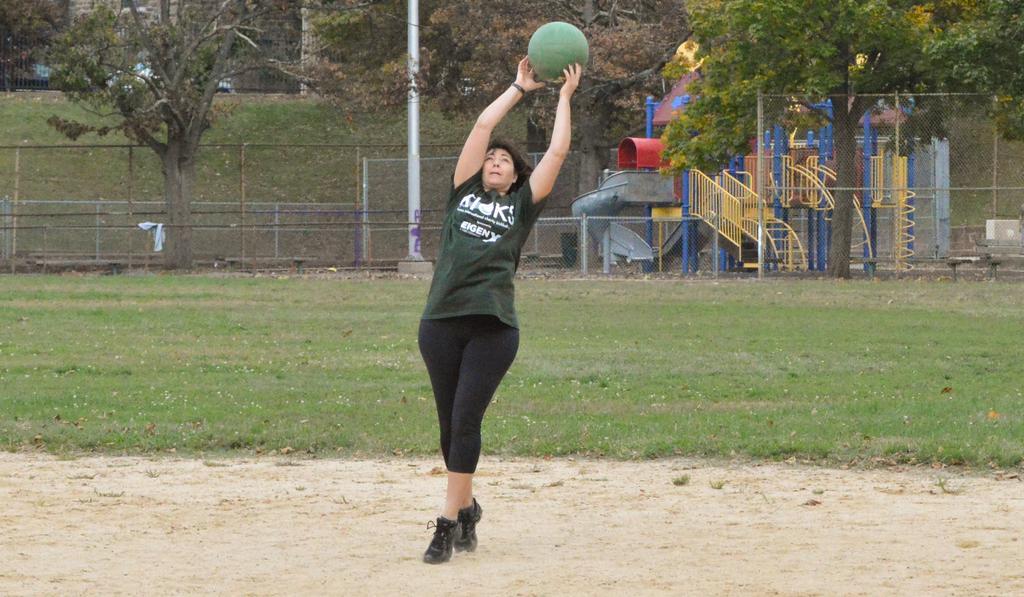Can you describe this image briefly? In this image I can see a woman holding a ball standing on the ground at the top I can see trees and fence, a staircase. 